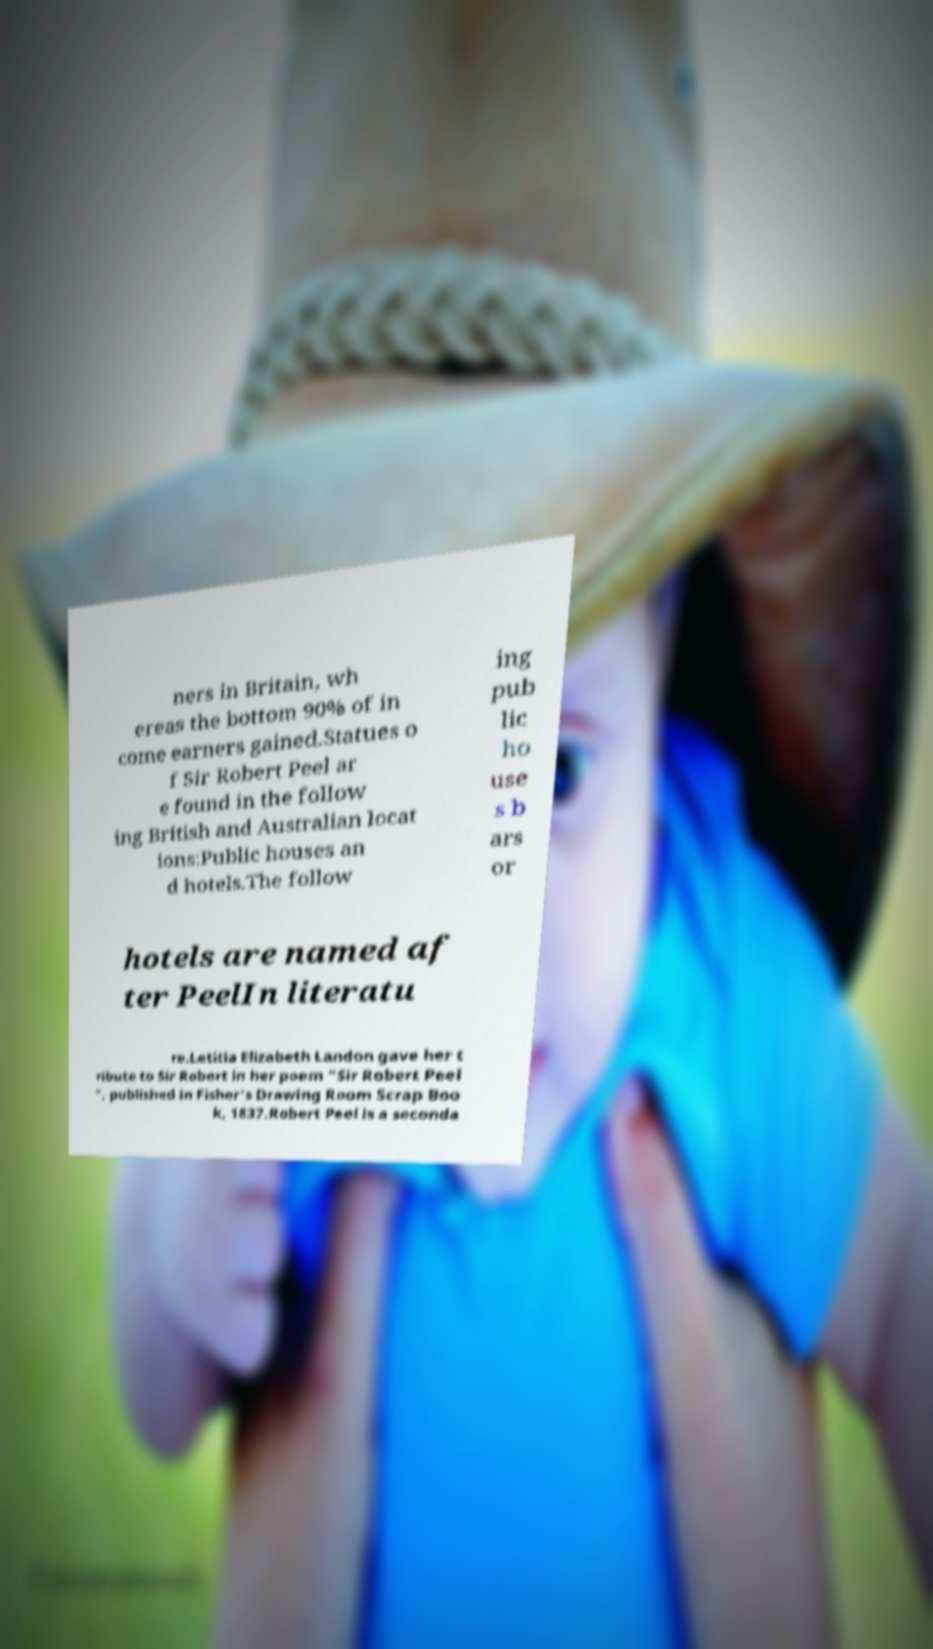Could you extract and type out the text from this image? ners in Britain, wh ereas the bottom 90% of in come earners gained.Statues o f Sir Robert Peel ar e found in the follow ing British and Australian locat ions:Public houses an d hotels.The follow ing pub lic ho use s b ars or hotels are named af ter PeelIn literatu re.Letitia Elizabeth Landon gave her t ribute to Sir Robert in her poem "Sir Robert Peel ", published in Fisher's Drawing Room Scrap Boo k, 1837.Robert Peel is a seconda 